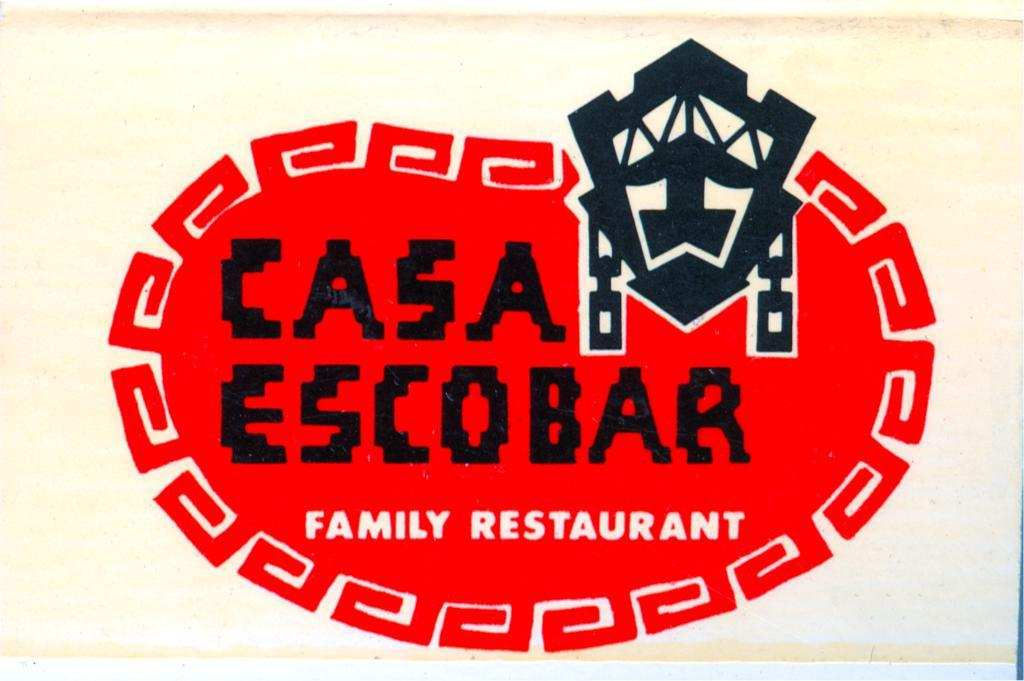<image>
Provide a brief description of the given image. The red and black logo for Casa Escobar Family Restaurant. 